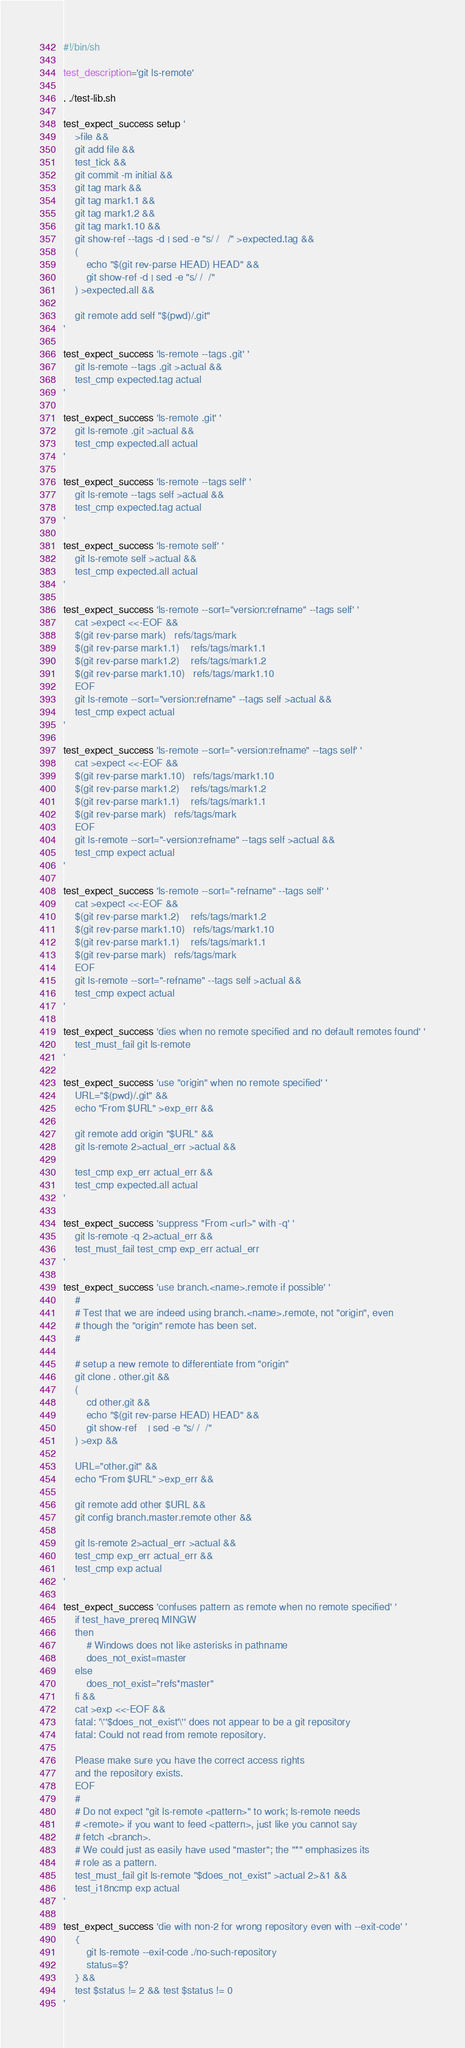Convert code to text. <code><loc_0><loc_0><loc_500><loc_500><_Bash_>#!/bin/sh

test_description='git ls-remote'

. ./test-lib.sh

test_expect_success setup '
	>file &&
	git add file &&
	test_tick &&
	git commit -m initial &&
	git tag mark &&
	git tag mark1.1 &&
	git tag mark1.2 &&
	git tag mark1.10 &&
	git show-ref --tags -d | sed -e "s/ /	/" >expected.tag &&
	(
		echo "$(git rev-parse HEAD)	HEAD" &&
		git show-ref -d	| sed -e "s/ /	/"
	) >expected.all &&

	git remote add self "$(pwd)/.git"
'

test_expect_success 'ls-remote --tags .git' '
	git ls-remote --tags .git >actual &&
	test_cmp expected.tag actual
'

test_expect_success 'ls-remote .git' '
	git ls-remote .git >actual &&
	test_cmp expected.all actual
'

test_expect_success 'ls-remote --tags self' '
	git ls-remote --tags self >actual &&
	test_cmp expected.tag actual
'

test_expect_success 'ls-remote self' '
	git ls-remote self >actual &&
	test_cmp expected.all actual
'

test_expect_success 'ls-remote --sort="version:refname" --tags self' '
	cat >expect <<-EOF &&
	$(git rev-parse mark)	refs/tags/mark
	$(git rev-parse mark1.1)	refs/tags/mark1.1
	$(git rev-parse mark1.2)	refs/tags/mark1.2
	$(git rev-parse mark1.10)	refs/tags/mark1.10
	EOF
	git ls-remote --sort="version:refname" --tags self >actual &&
	test_cmp expect actual
'

test_expect_success 'ls-remote --sort="-version:refname" --tags self' '
	cat >expect <<-EOF &&
	$(git rev-parse mark1.10)	refs/tags/mark1.10
	$(git rev-parse mark1.2)	refs/tags/mark1.2
	$(git rev-parse mark1.1)	refs/tags/mark1.1
	$(git rev-parse mark)	refs/tags/mark
	EOF
	git ls-remote --sort="-version:refname" --tags self >actual &&
	test_cmp expect actual
'

test_expect_success 'ls-remote --sort="-refname" --tags self' '
	cat >expect <<-EOF &&
	$(git rev-parse mark1.2)	refs/tags/mark1.2
	$(git rev-parse mark1.10)	refs/tags/mark1.10
	$(git rev-parse mark1.1)	refs/tags/mark1.1
	$(git rev-parse mark)	refs/tags/mark
	EOF
	git ls-remote --sort="-refname" --tags self >actual &&
	test_cmp expect actual
'

test_expect_success 'dies when no remote specified and no default remotes found' '
	test_must_fail git ls-remote
'

test_expect_success 'use "origin" when no remote specified' '
	URL="$(pwd)/.git" &&
	echo "From $URL" >exp_err &&

	git remote add origin "$URL" &&
	git ls-remote 2>actual_err >actual &&

	test_cmp exp_err actual_err &&
	test_cmp expected.all actual
'

test_expect_success 'suppress "From <url>" with -q' '
	git ls-remote -q 2>actual_err &&
	test_must_fail test_cmp exp_err actual_err
'

test_expect_success 'use branch.<name>.remote if possible' '
	#
	# Test that we are indeed using branch.<name>.remote, not "origin", even
	# though the "origin" remote has been set.
	#

	# setup a new remote to differentiate from "origin"
	git clone . other.git &&
	(
		cd other.git &&
		echo "$(git rev-parse HEAD)	HEAD" &&
		git show-ref	| sed -e "s/ /	/"
	) >exp &&

	URL="other.git" &&
	echo "From $URL" >exp_err &&

	git remote add other $URL &&
	git config branch.master.remote other &&

	git ls-remote 2>actual_err >actual &&
	test_cmp exp_err actual_err &&
	test_cmp exp actual
'

test_expect_success 'confuses pattern as remote when no remote specified' '
	if test_have_prereq MINGW
	then
		# Windows does not like asterisks in pathname
		does_not_exist=master
	else
		does_not_exist="refs*master"
	fi &&
	cat >exp <<-EOF &&
	fatal: '\''$does_not_exist'\'' does not appear to be a git repository
	fatal: Could not read from remote repository.

	Please make sure you have the correct access rights
	and the repository exists.
	EOF
	#
	# Do not expect "git ls-remote <pattern>" to work; ls-remote needs
	# <remote> if you want to feed <pattern>, just like you cannot say
	# fetch <branch>.
	# We could just as easily have used "master"; the "*" emphasizes its
	# role as a pattern.
	test_must_fail git ls-remote "$does_not_exist" >actual 2>&1 &&
	test_i18ncmp exp actual
'

test_expect_success 'die with non-2 for wrong repository even with --exit-code' '
	{
		git ls-remote --exit-code ./no-such-repository
		status=$?
	} &&
	test $status != 2 && test $status != 0
'
</code> 